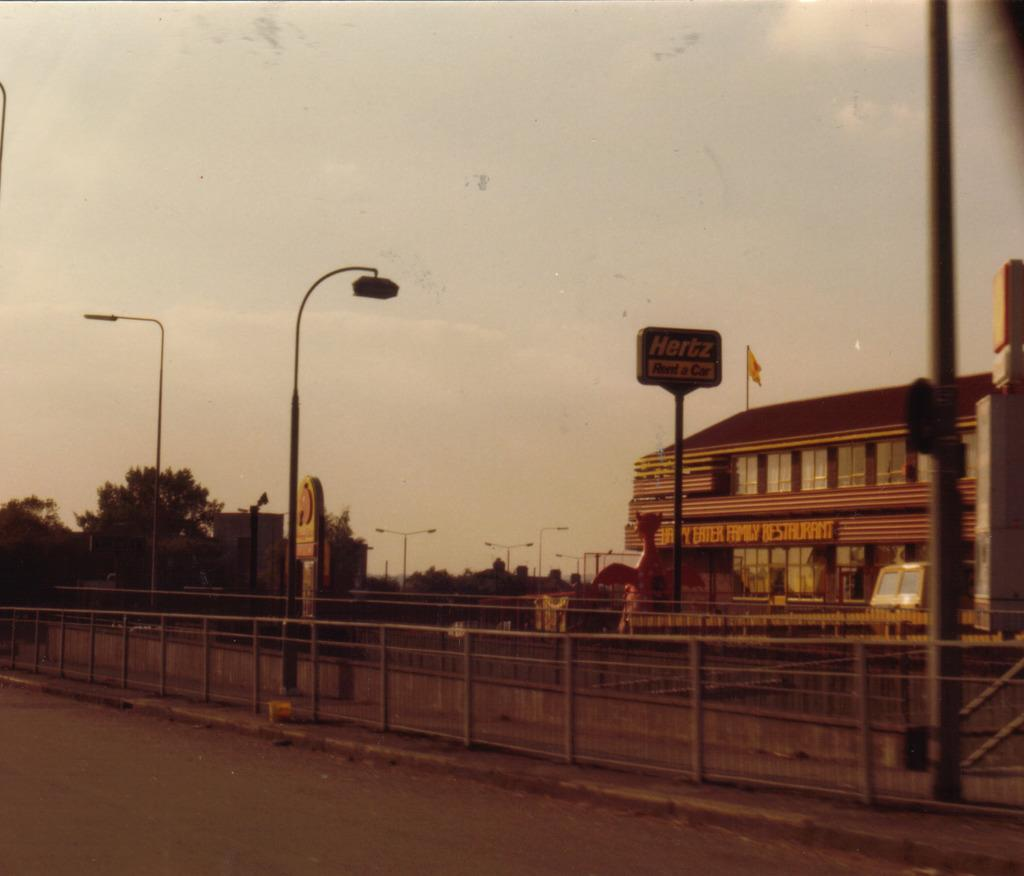What type of structure can be seen in the image? There is fencing, a road, a building, and trees visible in the image. What type of lighting is present in the image? There are street lights in the image. What other objects can be seen in the image? There are other objects in the image, but their specific details are not mentioned in the provided facts. What is on top of the building in the image? There is a flag on the roof of the building. What is visible at the top of the image? The sky is visible at the top of the image, and clouds are present in the sky. How does the airplane navigate its way through the order of the clouds in the image? There is no airplane present in the image; it only features fencing, a road, a building, trees, street lights, a flag, and the sky with clouds. 